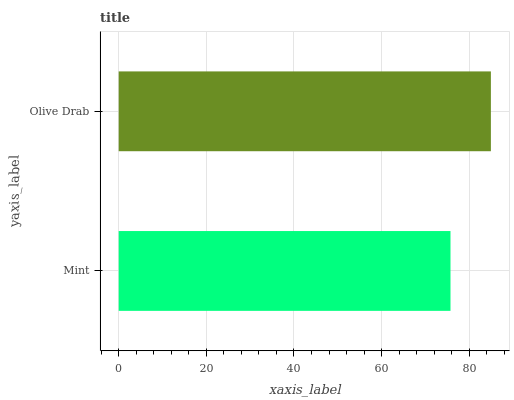Is Mint the minimum?
Answer yes or no. Yes. Is Olive Drab the maximum?
Answer yes or no. Yes. Is Olive Drab the minimum?
Answer yes or no. No. Is Olive Drab greater than Mint?
Answer yes or no. Yes. Is Mint less than Olive Drab?
Answer yes or no. Yes. Is Mint greater than Olive Drab?
Answer yes or no. No. Is Olive Drab less than Mint?
Answer yes or no. No. Is Olive Drab the high median?
Answer yes or no. Yes. Is Mint the low median?
Answer yes or no. Yes. Is Mint the high median?
Answer yes or no. No. Is Olive Drab the low median?
Answer yes or no. No. 